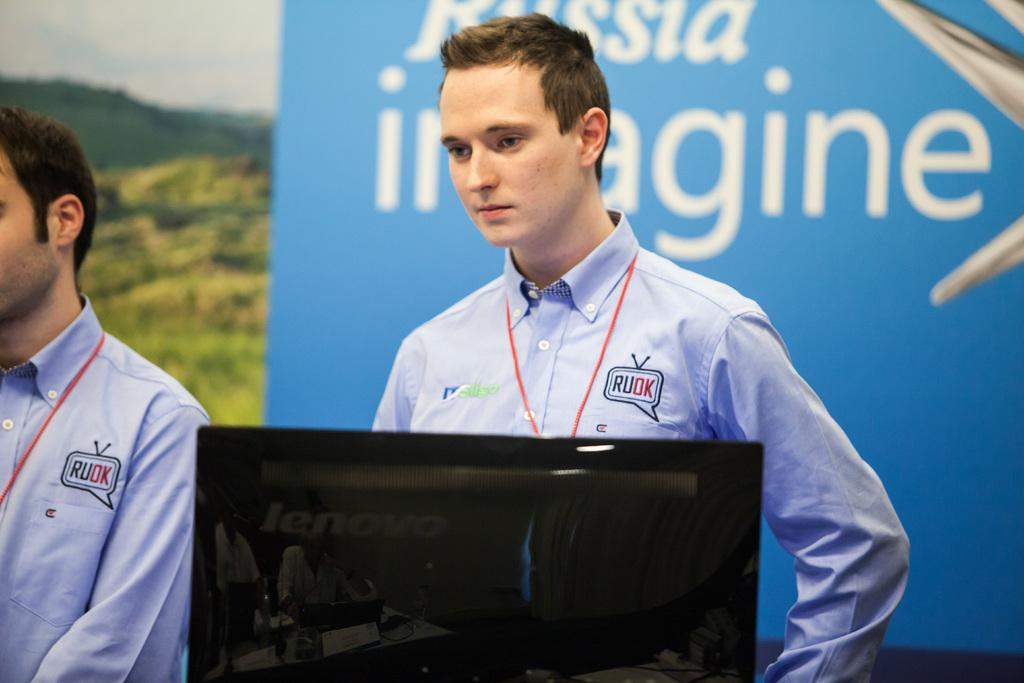How many people are in the image? There are two persons standing in the image. What are the persons looking at or interacting with? There is a monitor in front of the persons. What can be seen in the background of the image? There is a banner, trees, mountains, and the sky visible in the background of the image. What type of railway can be seen in the image? There is no railway present in the image. What company is represented by the banner in the background? The image does not provide enough information to determine the company represented by the banner. 